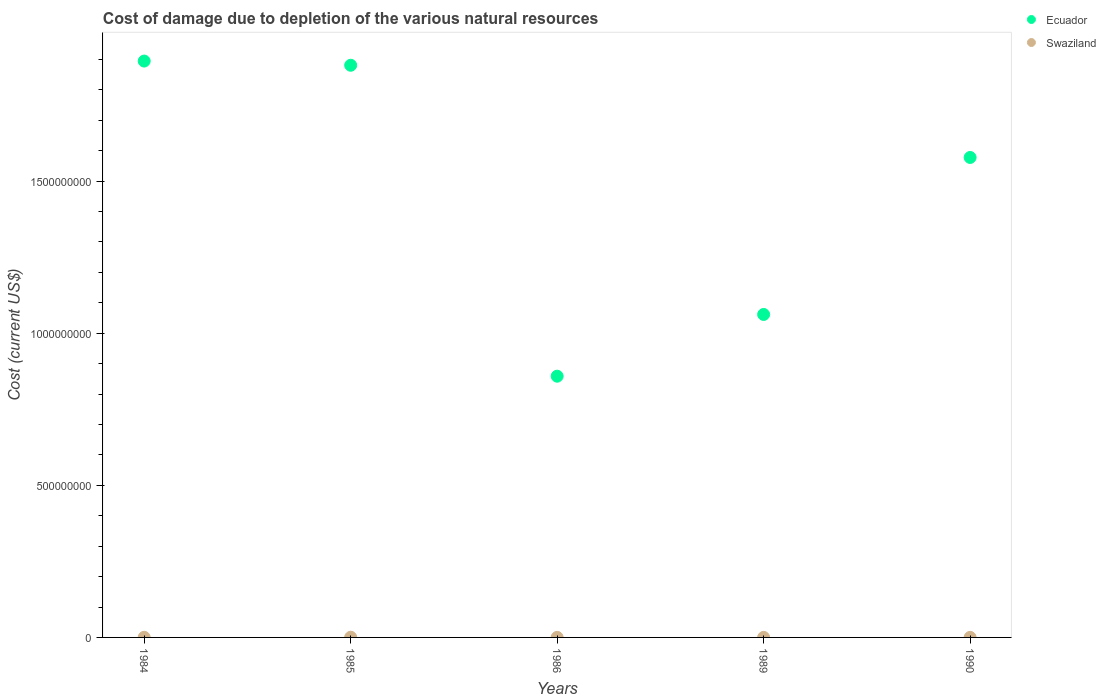How many different coloured dotlines are there?
Your response must be concise. 2. What is the cost of damage caused due to the depletion of various natural resources in Ecuador in 1990?
Your response must be concise. 1.58e+09. Across all years, what is the maximum cost of damage caused due to the depletion of various natural resources in Swaziland?
Make the answer very short. 7.02e+05. Across all years, what is the minimum cost of damage caused due to the depletion of various natural resources in Swaziland?
Your response must be concise. 1.57e+05. In which year was the cost of damage caused due to the depletion of various natural resources in Swaziland minimum?
Provide a short and direct response. 1989. What is the total cost of damage caused due to the depletion of various natural resources in Swaziland in the graph?
Your answer should be very brief. 1.66e+06. What is the difference between the cost of damage caused due to the depletion of various natural resources in Swaziland in 1985 and that in 1989?
Your response must be concise. 5.45e+05. What is the difference between the cost of damage caused due to the depletion of various natural resources in Swaziland in 1985 and the cost of damage caused due to the depletion of various natural resources in Ecuador in 1990?
Provide a short and direct response. -1.58e+09. What is the average cost of damage caused due to the depletion of various natural resources in Ecuador per year?
Offer a terse response. 1.45e+09. In the year 1986, what is the difference between the cost of damage caused due to the depletion of various natural resources in Swaziland and cost of damage caused due to the depletion of various natural resources in Ecuador?
Keep it short and to the point. -8.58e+08. What is the ratio of the cost of damage caused due to the depletion of various natural resources in Swaziland in 1986 to that in 1989?
Make the answer very short. 1.39. Is the cost of damage caused due to the depletion of various natural resources in Swaziland in 1985 less than that in 1986?
Keep it short and to the point. No. What is the difference between the highest and the second highest cost of damage caused due to the depletion of various natural resources in Ecuador?
Your response must be concise. 1.38e+07. What is the difference between the highest and the lowest cost of damage caused due to the depletion of various natural resources in Ecuador?
Make the answer very short. 1.04e+09. In how many years, is the cost of damage caused due to the depletion of various natural resources in Ecuador greater than the average cost of damage caused due to the depletion of various natural resources in Ecuador taken over all years?
Provide a short and direct response. 3. Does the cost of damage caused due to the depletion of various natural resources in Swaziland monotonically increase over the years?
Ensure brevity in your answer.  No. How many dotlines are there?
Your answer should be very brief. 2. How many years are there in the graph?
Give a very brief answer. 5. What is the difference between two consecutive major ticks on the Y-axis?
Keep it short and to the point. 5.00e+08. Does the graph contain grids?
Offer a very short reply. No. Where does the legend appear in the graph?
Ensure brevity in your answer.  Top right. How many legend labels are there?
Give a very brief answer. 2. How are the legend labels stacked?
Offer a terse response. Vertical. What is the title of the graph?
Ensure brevity in your answer.  Cost of damage due to depletion of the various natural resources. Does "Faeroe Islands" appear as one of the legend labels in the graph?
Your response must be concise. No. What is the label or title of the Y-axis?
Your answer should be very brief. Cost (current US$). What is the Cost (current US$) in Ecuador in 1984?
Offer a very short reply. 1.89e+09. What is the Cost (current US$) in Swaziland in 1984?
Give a very brief answer. 3.92e+05. What is the Cost (current US$) of Ecuador in 1985?
Your answer should be very brief. 1.88e+09. What is the Cost (current US$) in Swaziland in 1985?
Keep it short and to the point. 7.02e+05. What is the Cost (current US$) of Ecuador in 1986?
Keep it short and to the point. 8.59e+08. What is the Cost (current US$) in Swaziland in 1986?
Your answer should be very brief. 2.18e+05. What is the Cost (current US$) in Ecuador in 1989?
Provide a short and direct response. 1.06e+09. What is the Cost (current US$) of Swaziland in 1989?
Provide a succinct answer. 1.57e+05. What is the Cost (current US$) in Ecuador in 1990?
Your answer should be very brief. 1.58e+09. What is the Cost (current US$) in Swaziland in 1990?
Make the answer very short. 1.89e+05. Across all years, what is the maximum Cost (current US$) in Ecuador?
Your answer should be very brief. 1.89e+09. Across all years, what is the maximum Cost (current US$) of Swaziland?
Your answer should be compact. 7.02e+05. Across all years, what is the minimum Cost (current US$) in Ecuador?
Keep it short and to the point. 8.59e+08. Across all years, what is the minimum Cost (current US$) of Swaziland?
Your answer should be compact. 1.57e+05. What is the total Cost (current US$) of Ecuador in the graph?
Offer a terse response. 7.27e+09. What is the total Cost (current US$) of Swaziland in the graph?
Give a very brief answer. 1.66e+06. What is the difference between the Cost (current US$) in Ecuador in 1984 and that in 1985?
Provide a succinct answer. 1.38e+07. What is the difference between the Cost (current US$) of Swaziland in 1984 and that in 1985?
Give a very brief answer. -3.10e+05. What is the difference between the Cost (current US$) in Ecuador in 1984 and that in 1986?
Your response must be concise. 1.04e+09. What is the difference between the Cost (current US$) in Swaziland in 1984 and that in 1986?
Your response must be concise. 1.75e+05. What is the difference between the Cost (current US$) in Ecuador in 1984 and that in 1989?
Your answer should be compact. 8.33e+08. What is the difference between the Cost (current US$) of Swaziland in 1984 and that in 1989?
Provide a succinct answer. 2.36e+05. What is the difference between the Cost (current US$) of Ecuador in 1984 and that in 1990?
Offer a terse response. 3.17e+08. What is the difference between the Cost (current US$) of Swaziland in 1984 and that in 1990?
Provide a short and direct response. 2.03e+05. What is the difference between the Cost (current US$) of Ecuador in 1985 and that in 1986?
Provide a short and direct response. 1.02e+09. What is the difference between the Cost (current US$) of Swaziland in 1985 and that in 1986?
Keep it short and to the point. 4.84e+05. What is the difference between the Cost (current US$) in Ecuador in 1985 and that in 1989?
Ensure brevity in your answer.  8.19e+08. What is the difference between the Cost (current US$) of Swaziland in 1985 and that in 1989?
Ensure brevity in your answer.  5.45e+05. What is the difference between the Cost (current US$) in Ecuador in 1985 and that in 1990?
Offer a very short reply. 3.03e+08. What is the difference between the Cost (current US$) of Swaziland in 1985 and that in 1990?
Provide a succinct answer. 5.13e+05. What is the difference between the Cost (current US$) of Ecuador in 1986 and that in 1989?
Your response must be concise. -2.03e+08. What is the difference between the Cost (current US$) of Swaziland in 1986 and that in 1989?
Your response must be concise. 6.09e+04. What is the difference between the Cost (current US$) in Ecuador in 1986 and that in 1990?
Ensure brevity in your answer.  -7.19e+08. What is the difference between the Cost (current US$) in Swaziland in 1986 and that in 1990?
Your response must be concise. 2.83e+04. What is the difference between the Cost (current US$) in Ecuador in 1989 and that in 1990?
Provide a short and direct response. -5.16e+08. What is the difference between the Cost (current US$) in Swaziland in 1989 and that in 1990?
Make the answer very short. -3.26e+04. What is the difference between the Cost (current US$) of Ecuador in 1984 and the Cost (current US$) of Swaziland in 1985?
Ensure brevity in your answer.  1.89e+09. What is the difference between the Cost (current US$) in Ecuador in 1984 and the Cost (current US$) in Swaziland in 1986?
Your answer should be compact. 1.89e+09. What is the difference between the Cost (current US$) of Ecuador in 1984 and the Cost (current US$) of Swaziland in 1989?
Your answer should be very brief. 1.89e+09. What is the difference between the Cost (current US$) in Ecuador in 1984 and the Cost (current US$) in Swaziland in 1990?
Keep it short and to the point. 1.89e+09. What is the difference between the Cost (current US$) of Ecuador in 1985 and the Cost (current US$) of Swaziland in 1986?
Keep it short and to the point. 1.88e+09. What is the difference between the Cost (current US$) of Ecuador in 1985 and the Cost (current US$) of Swaziland in 1989?
Ensure brevity in your answer.  1.88e+09. What is the difference between the Cost (current US$) of Ecuador in 1985 and the Cost (current US$) of Swaziland in 1990?
Your answer should be very brief. 1.88e+09. What is the difference between the Cost (current US$) of Ecuador in 1986 and the Cost (current US$) of Swaziland in 1989?
Keep it short and to the point. 8.58e+08. What is the difference between the Cost (current US$) in Ecuador in 1986 and the Cost (current US$) in Swaziland in 1990?
Offer a terse response. 8.58e+08. What is the difference between the Cost (current US$) in Ecuador in 1989 and the Cost (current US$) in Swaziland in 1990?
Provide a short and direct response. 1.06e+09. What is the average Cost (current US$) in Ecuador per year?
Offer a terse response. 1.45e+09. What is the average Cost (current US$) in Swaziland per year?
Ensure brevity in your answer.  3.31e+05. In the year 1984, what is the difference between the Cost (current US$) of Ecuador and Cost (current US$) of Swaziland?
Provide a succinct answer. 1.89e+09. In the year 1985, what is the difference between the Cost (current US$) of Ecuador and Cost (current US$) of Swaziland?
Your answer should be very brief. 1.88e+09. In the year 1986, what is the difference between the Cost (current US$) in Ecuador and Cost (current US$) in Swaziland?
Offer a very short reply. 8.58e+08. In the year 1989, what is the difference between the Cost (current US$) of Ecuador and Cost (current US$) of Swaziland?
Give a very brief answer. 1.06e+09. In the year 1990, what is the difference between the Cost (current US$) in Ecuador and Cost (current US$) in Swaziland?
Offer a terse response. 1.58e+09. What is the ratio of the Cost (current US$) of Ecuador in 1984 to that in 1985?
Offer a very short reply. 1.01. What is the ratio of the Cost (current US$) in Swaziland in 1984 to that in 1985?
Ensure brevity in your answer.  0.56. What is the ratio of the Cost (current US$) in Ecuador in 1984 to that in 1986?
Your response must be concise. 2.21. What is the ratio of the Cost (current US$) in Swaziland in 1984 to that in 1986?
Give a very brief answer. 1.8. What is the ratio of the Cost (current US$) of Ecuador in 1984 to that in 1989?
Keep it short and to the point. 1.78. What is the ratio of the Cost (current US$) in Swaziland in 1984 to that in 1989?
Keep it short and to the point. 2.5. What is the ratio of the Cost (current US$) in Ecuador in 1984 to that in 1990?
Your answer should be compact. 1.2. What is the ratio of the Cost (current US$) in Swaziland in 1984 to that in 1990?
Your response must be concise. 2.07. What is the ratio of the Cost (current US$) in Ecuador in 1985 to that in 1986?
Provide a succinct answer. 2.19. What is the ratio of the Cost (current US$) in Swaziland in 1985 to that in 1986?
Ensure brevity in your answer.  3.23. What is the ratio of the Cost (current US$) of Ecuador in 1985 to that in 1989?
Your answer should be very brief. 1.77. What is the ratio of the Cost (current US$) in Swaziland in 1985 to that in 1989?
Ensure brevity in your answer.  4.48. What is the ratio of the Cost (current US$) of Ecuador in 1985 to that in 1990?
Your answer should be compact. 1.19. What is the ratio of the Cost (current US$) of Swaziland in 1985 to that in 1990?
Your answer should be very brief. 3.71. What is the ratio of the Cost (current US$) in Ecuador in 1986 to that in 1989?
Ensure brevity in your answer.  0.81. What is the ratio of the Cost (current US$) in Swaziland in 1986 to that in 1989?
Make the answer very short. 1.39. What is the ratio of the Cost (current US$) of Ecuador in 1986 to that in 1990?
Offer a very short reply. 0.54. What is the ratio of the Cost (current US$) of Swaziland in 1986 to that in 1990?
Offer a terse response. 1.15. What is the ratio of the Cost (current US$) of Ecuador in 1989 to that in 1990?
Make the answer very short. 0.67. What is the ratio of the Cost (current US$) of Swaziland in 1989 to that in 1990?
Your response must be concise. 0.83. What is the difference between the highest and the second highest Cost (current US$) of Ecuador?
Provide a succinct answer. 1.38e+07. What is the difference between the highest and the second highest Cost (current US$) of Swaziland?
Offer a terse response. 3.10e+05. What is the difference between the highest and the lowest Cost (current US$) of Ecuador?
Provide a succinct answer. 1.04e+09. What is the difference between the highest and the lowest Cost (current US$) in Swaziland?
Offer a very short reply. 5.45e+05. 